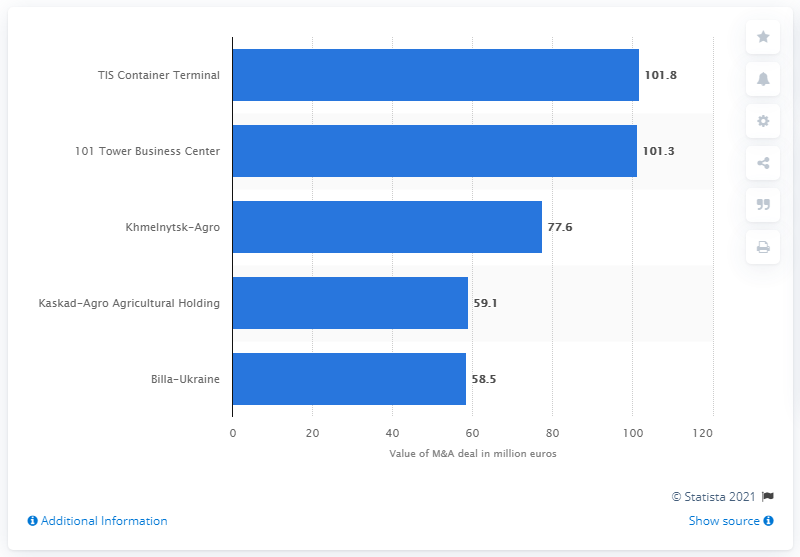Give some essential details in this illustration. The value of Billa-Ukraine was 58.5.. Dragon Capital Investments paid $101.8 million for the 101 Tower Business Center. The deal in Ukraine cost 101.8. 